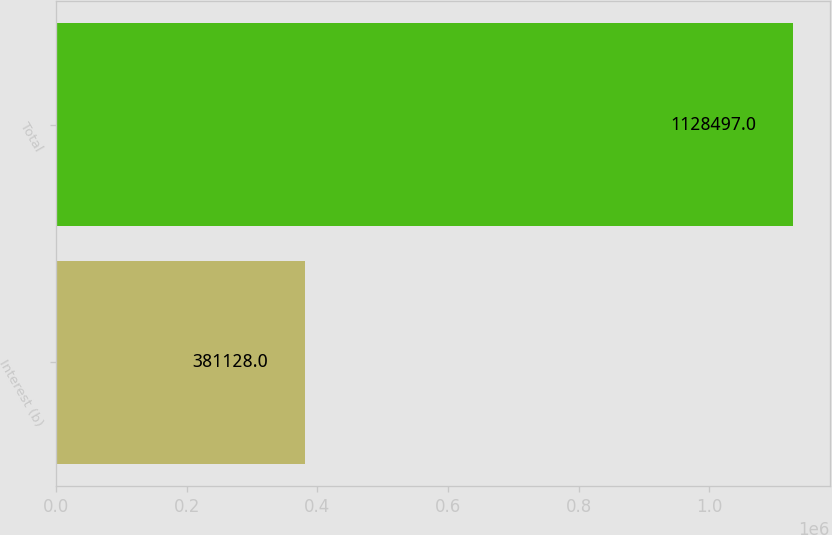Convert chart. <chart><loc_0><loc_0><loc_500><loc_500><bar_chart><fcel>Interest (b)<fcel>Total<nl><fcel>381128<fcel>1.1285e+06<nl></chart> 